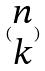<formula> <loc_0><loc_0><loc_500><loc_500>( \begin{matrix} n \\ k \end{matrix} )</formula> 